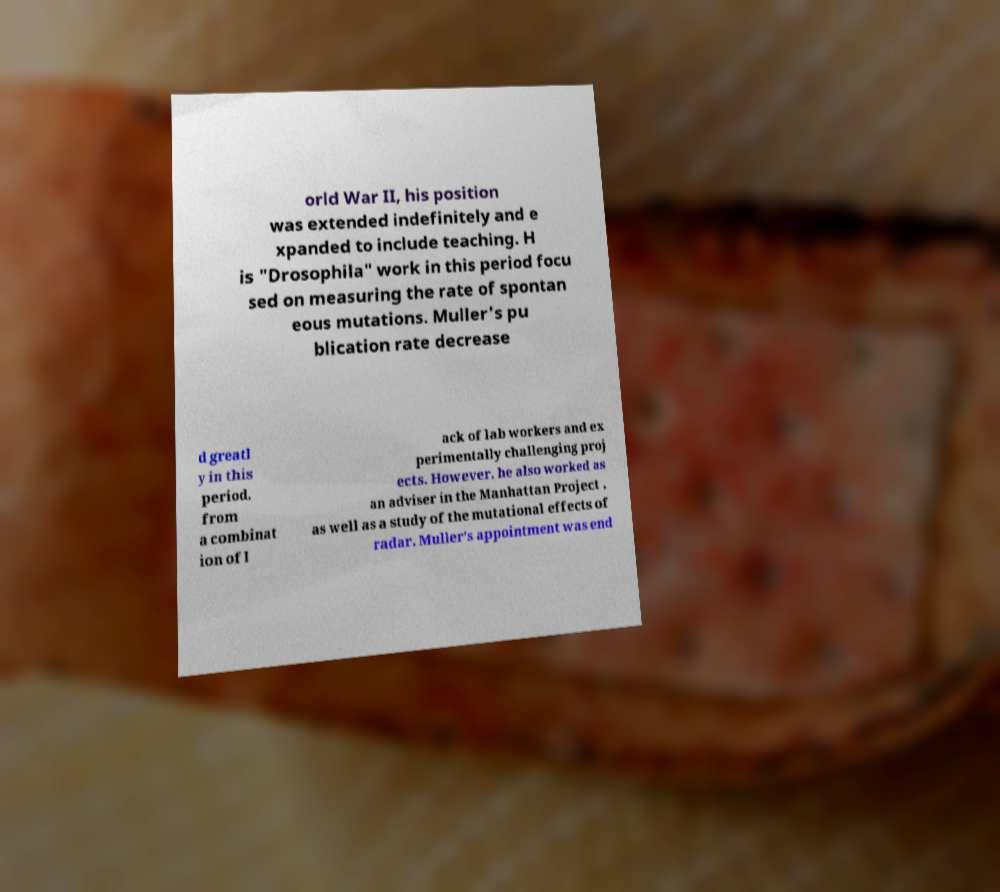Can you accurately transcribe the text from the provided image for me? orld War II, his position was extended indefinitely and e xpanded to include teaching. H is "Drosophila" work in this period focu sed on measuring the rate of spontan eous mutations. Muller's pu blication rate decrease d greatl y in this period, from a combinat ion of l ack of lab workers and ex perimentally challenging proj ects. However, he also worked as an adviser in the Manhattan Project , as well as a study of the mutational effects of radar. Muller's appointment was end 